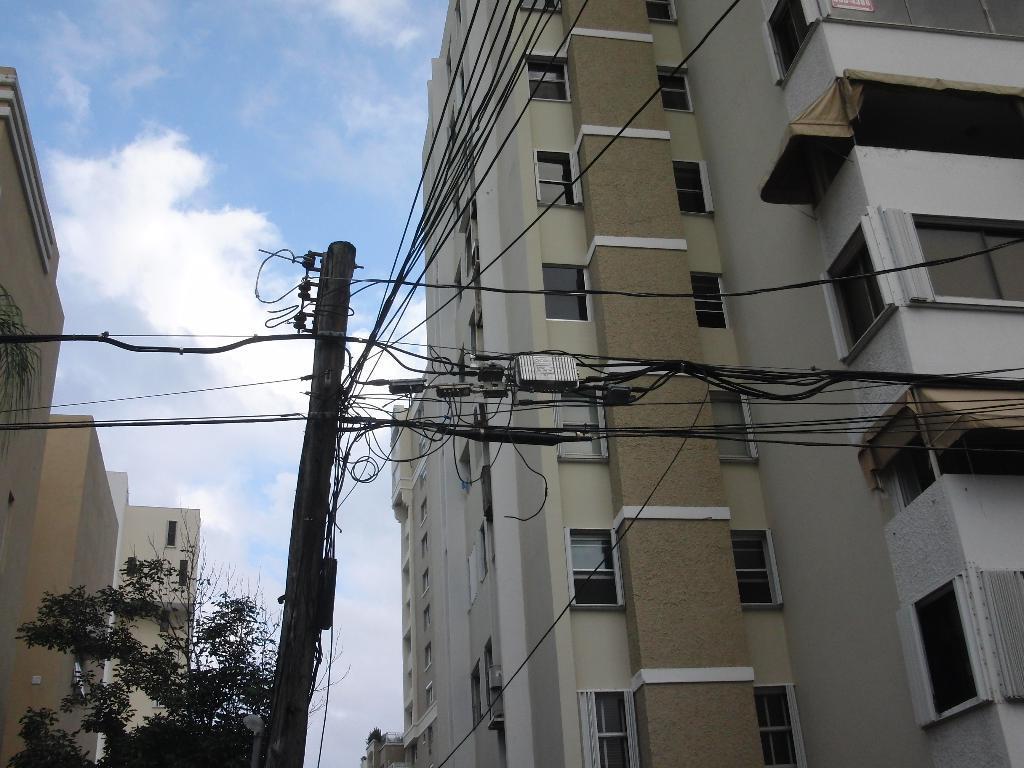How would you summarize this image in a sentence or two? This is the picture of a place where we have some buildings to which there are some windows and also we can also see a pole to which there are some wires. 